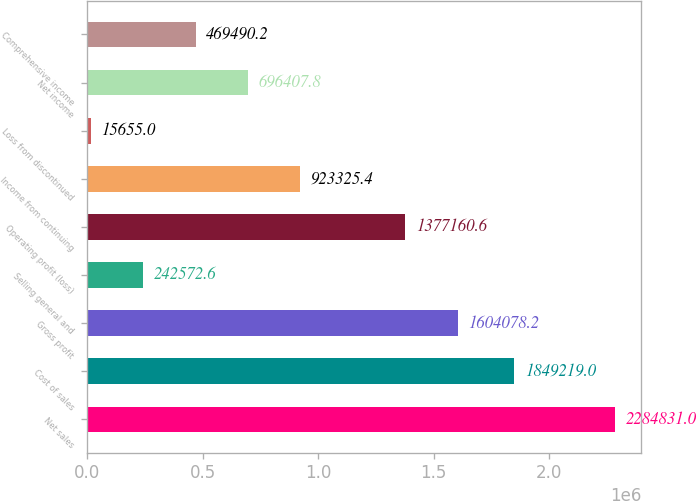Convert chart to OTSL. <chart><loc_0><loc_0><loc_500><loc_500><bar_chart><fcel>Net sales<fcel>Cost of sales<fcel>Gross profit<fcel>Selling general and<fcel>Operating profit (loss)<fcel>Income from continuing<fcel>Loss from discontinued<fcel>Net income<fcel>Comprehensive income<nl><fcel>2.28483e+06<fcel>1.84922e+06<fcel>1.60408e+06<fcel>242573<fcel>1.37716e+06<fcel>923325<fcel>15655<fcel>696408<fcel>469490<nl></chart> 